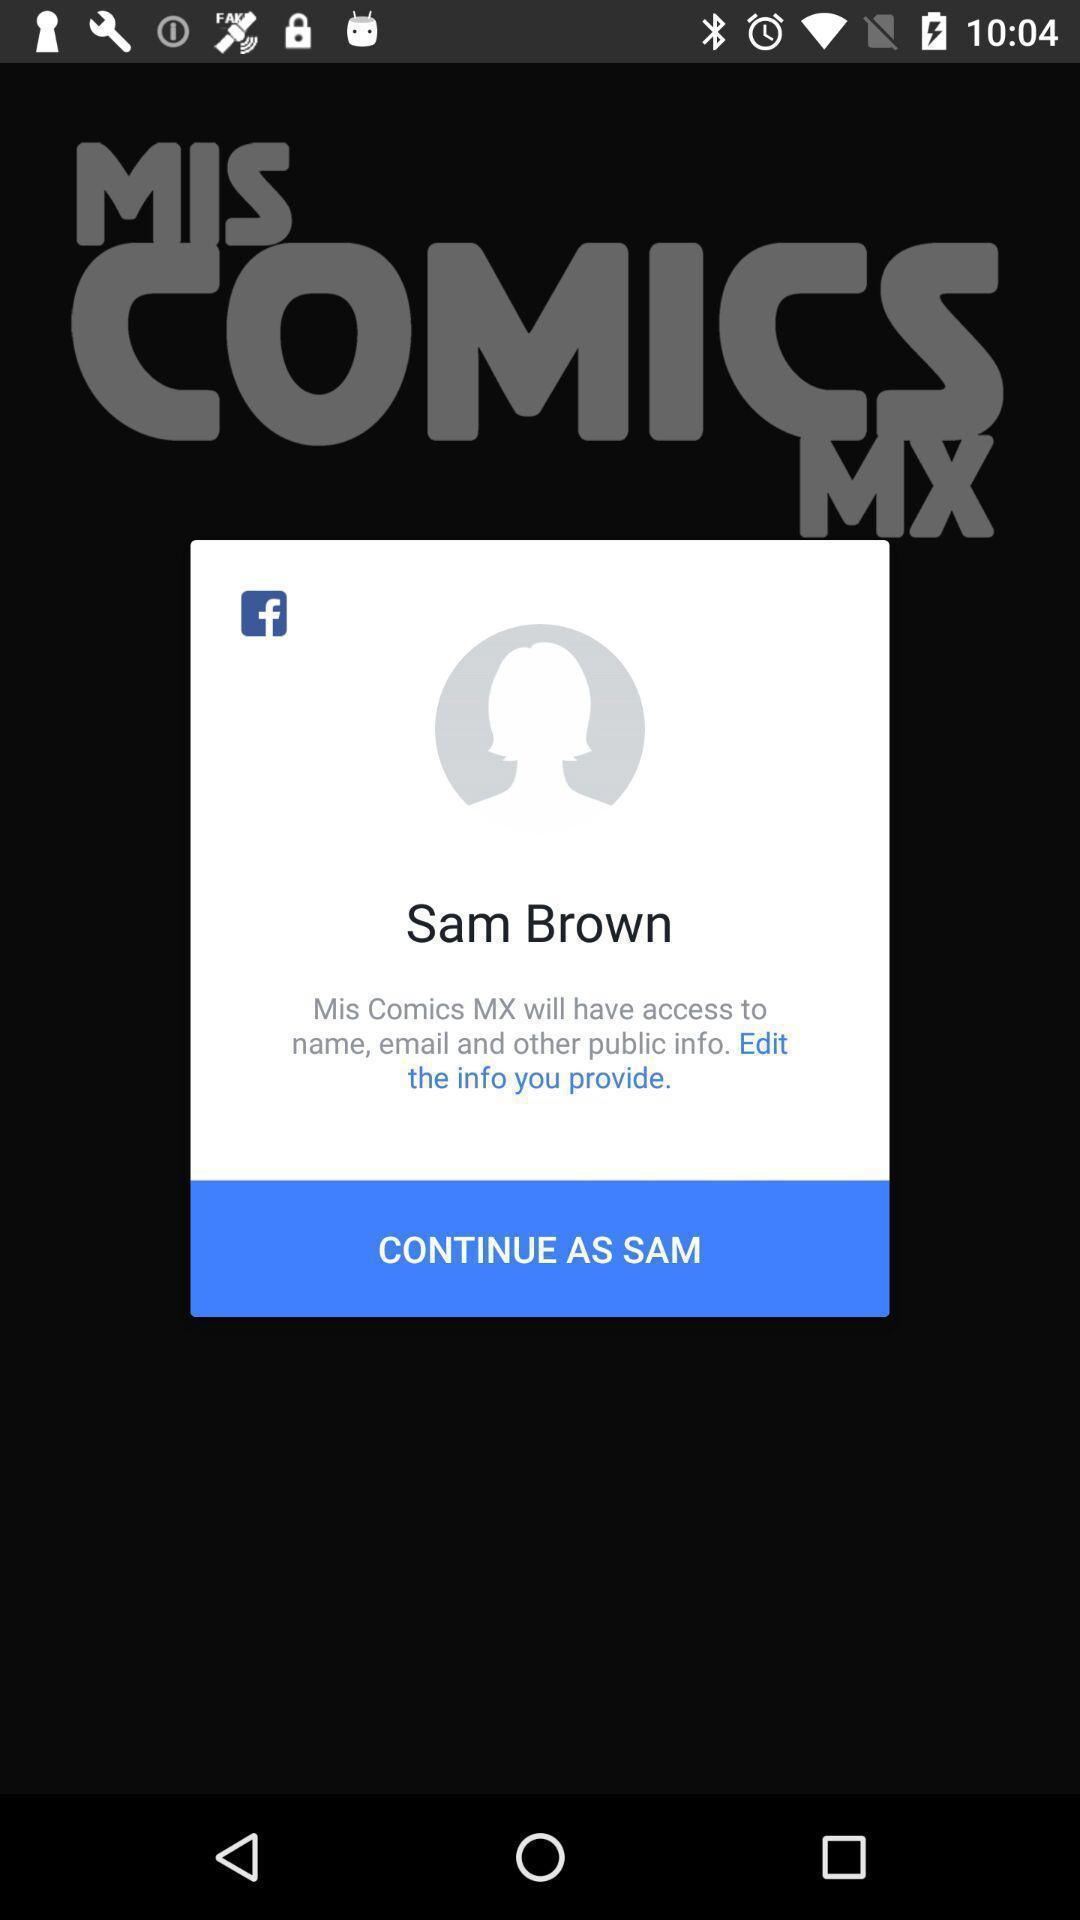Summarize the information in this screenshot. Pop-up displaying profile to login. 